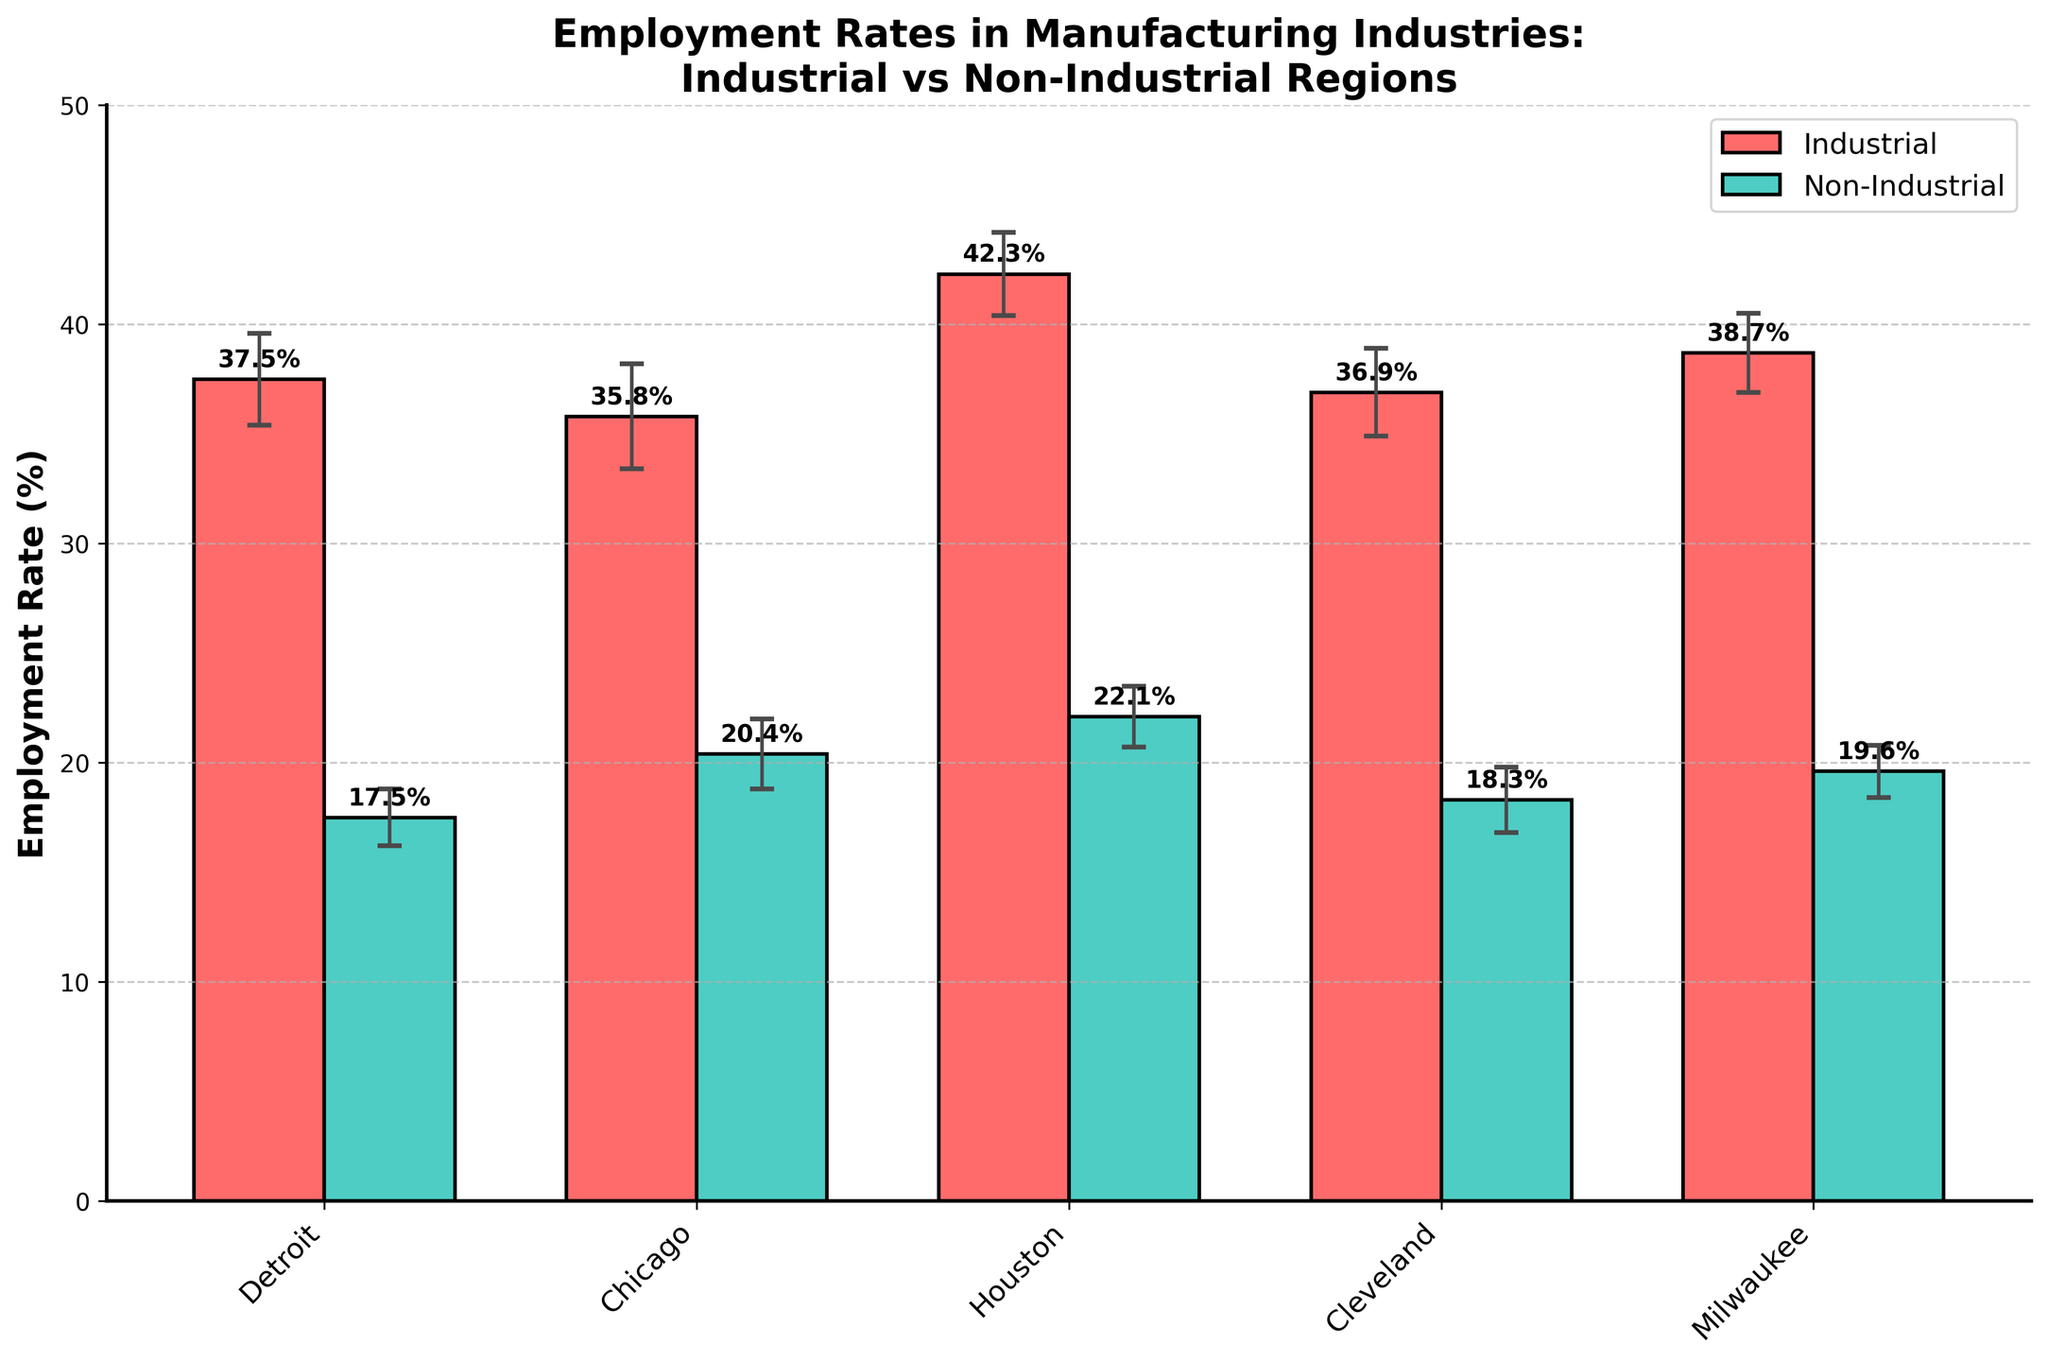Which region has the highest employment rate in manufacturing industries? The bar chart shows the employment rates for various cities. Houston (Industrial region) has the highest employment rate at 42.3%.
Answer: Houston (Industrial) What is the title of the chart? The chart's title is displayed at the top of the figure. It reads "Employment Rates in Manufacturing Industries: Industrial vs Non-Industrial Regions".
Answer: Employment Rates in Manufacturing Industries: Industrial vs Non-Industrial Regions Which non-industrial region has the highest employment rate in manufacturing industries? Among the non-industrial regions, the city with the highest employment rate is Austin, which has an employment rate of 22.1%.
Answer: Austin What is the difference between the employment rates of Detroit and San Francisco? The employment rate for Detroit is 37.5%, and for San Francisco, it is 17.5%. The difference between these rates is 37.5% - 17.5% = 20%.
Answer: 20% Which regions have error bars of 1.9 or smaller? From observing the error bars in the chart, Houston (1.9), Milwaukee (1.8), Austin (1.4), San Francisco (1.3), and Denver (1.2) have error bars that are 1.9 or smaller.
Answer: Houston, Milwaukee, Austin, San Francisco, Denver How many cities are represented in the non-industrial region? By counting the bars labeled as non-industrial, there are five cities: San Francisco, Seattle, Austin, Boston, and Denver.
Answer: 5 What is the average employment rate of the industrial regions shown? The employment rates for the industrial regions are 37.5%, 35.8%, 42.3%, 36.9%, and 38.7%. The average is calculated as (37.5 + 35.8 + 42.3 + 36.9 + 38.7) / 5 = 38.24%.
Answer: 38.24% Which region has the smallest error bar among the industrial regions? Among the industrial regions, Milwaukee has the smallest error bar, which is 1.8%.
Answer: Milwaukee Is the employment rate of Cleveland higher than that of Denver? Cleveland's employment rate is 36.9%, while Denver's employment rate is 19.6%. Cleveland's rate is higher.
Answer: Yes Which two cities have the closest employment rates in the industrial region? In the industrial region, Detroit and Cleveland have very close employment rates of 37.5% and 36.9%, respectively. The difference between them is 0.6%.
Answer: Detroit and Cleveland 